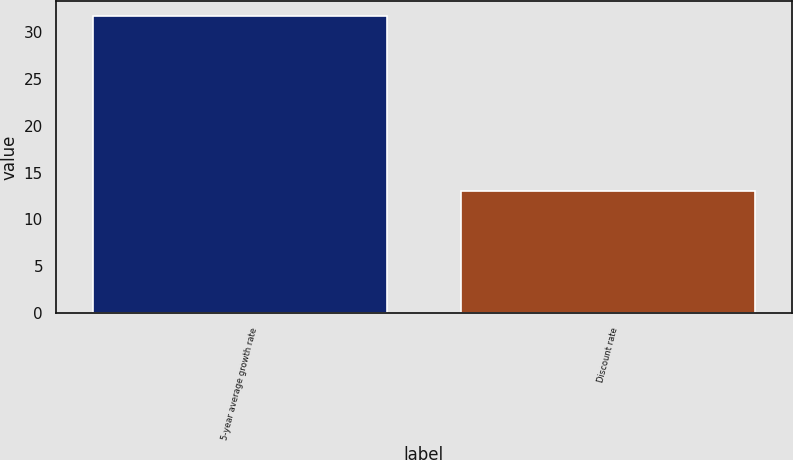Convert chart. <chart><loc_0><loc_0><loc_500><loc_500><bar_chart><fcel>5-year average growth rate<fcel>Discount rate<nl><fcel>31.7<fcel>13<nl></chart> 